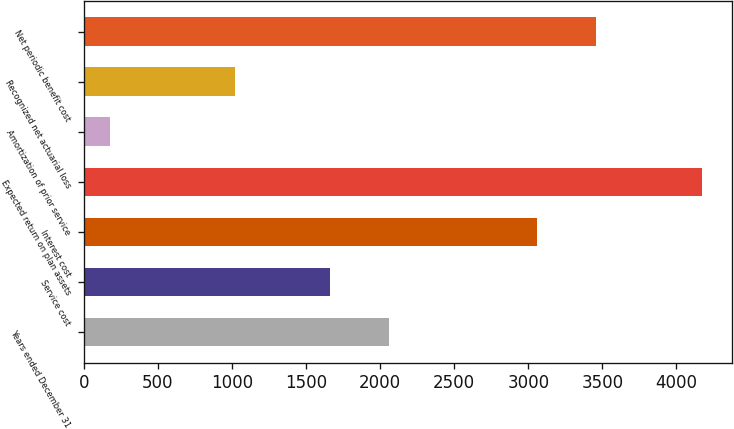Convert chart to OTSL. <chart><loc_0><loc_0><loc_500><loc_500><bar_chart><fcel>Years ended December 31<fcel>Service cost<fcel>Interest cost<fcel>Expected return on plan assets<fcel>Amortization of prior service<fcel>Recognized net actuarial loss<fcel>Net periodic benefit cost<nl><fcel>2060.2<fcel>1661<fcel>3058<fcel>4169<fcel>177<fcel>1020<fcel>3457.2<nl></chart> 